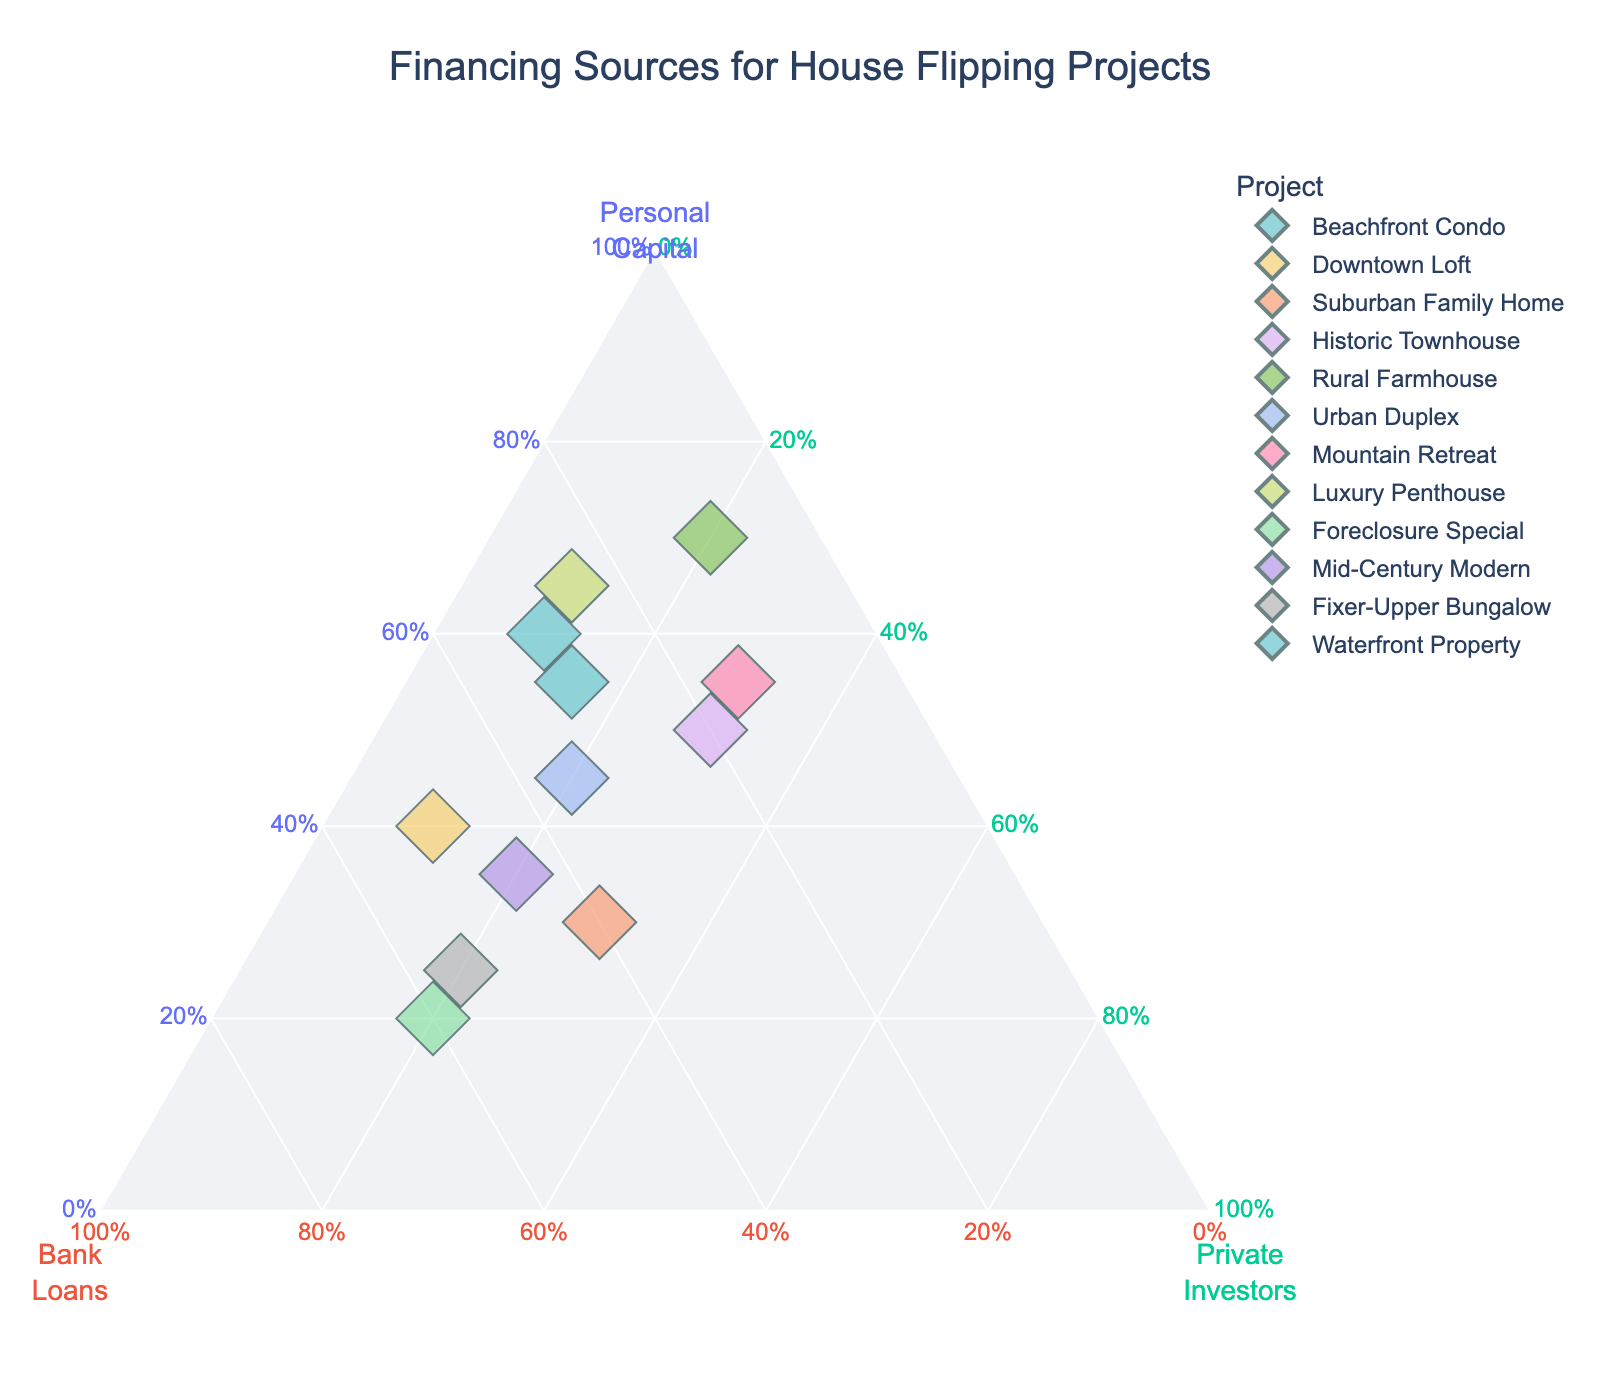How many different projects are shown in the plot? Count the number of distinct project names listed in the hover information of the plot. There are 12 unique projects: Beachfront Condo, Downtown Loft, Suburban Family Home, Historic Townhouse, Rural Farmhouse, Urban Duplex, Mountain Retreat, Luxury Penthouse, Foreclosure Special, Mid-Century Modern, Fixer-Upper Bungalow, and Waterfront Property.
Answer: 12 Which project relies the most on Bank Loans for its financing? Identify the point located closest to the vertex labeled "Bank Loans". The project closest to this vertex is Foreclosure Special.
Answer: Foreclosure Special What's the title of the plot? Read the title displayed at the top of the plot. The title is "Financing Sources for House Flipping Projects".
Answer: Financing Sources for House Flipping Projects What is the maximum percentage of Personal Capital used in any project? Examine the points to find the one with the highest value closer to the “Personal Capital” vertex. The highest value is 70% for the Rural Farmhouse.
Answer: 70% Which project has an equal percentage of financing from Personal Capital and Private Investors? Compare the points ensuring the two vertices "Personal Capital" and "Private Investors" have equal values for any project. The Historic Townhouse shows an equal distribution of 30% each.
Answer: Historic Townhouse What's the average percentage of Personal Capital used across all projects? Sum all the percentages of Personal Capital for each project, then divide by the number of projects. The calculation is (60+40+30+50+70+45+55+65+20+35+25+55)/12 = 45%.
Answer: 45% Which two projects have the most similar compositions in their sources of financing? Identify the two points that are closest to each other in location within the plot, indicating similar compositions. The Urban Duplex and Mid-Century Modern have quite similar financing compositions, each with 45% and 35% for Personal Capital, 35% and 45% for Bank Loans, and 20% for Private Investors.
Answer: Urban Duplex and Mid-Century Modern Which project uses the least percentage of Private Investors? Locate the point farthest from the "Private Investors" vertex. Luxury Penthouse and Beachfront Condo both have the lowest at 10%.
Answer: Luxury Penthouse and Beachfront Condo Arrange the projects in descending order of their Bank Loan percentage. Identify and list each project by their Bank Loans percentage and sort them from highest to lowest. The order is Foreclosure Special (60%), Fixer-Upper Bungalow (55%), Downtown Loft (50%), Mid-Century Modern (45%), Suburban Family Home (40%), Urban Duplex (35%), Waterfront Property (30%), Beachfront Condo (30%), Historic Townhouse (20%), Mountain Retreat (15%), Rural Farmhouse (10%), and Luxury Penthouse (25%).
Answer: Foreclosure Special, Fixer-Upper Bungalow, Downtown Loft, Mid-Century Modern, Suburban Family Home, Urban Duplex, Waterfront Property, Beachfront Condo, Historic Townhouse, Mountain Retreat, Rural Farmhouse, Luxury Penthouse What is the total proportion of financing sourced from Private Investors for all projects combined? Add up all percentages of Private Investors for each project. The calculation is 10+10+30+30+20+20+30+10+20+20+20+15 = 235%.
Answer: 235% 